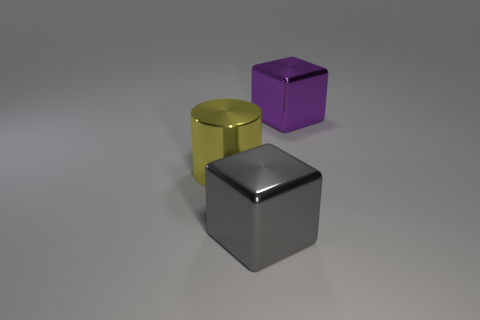What color is the large cube that is made of the same material as the big purple thing? The large cube that shares the smooth, metallic material with the big purple object is gray. 